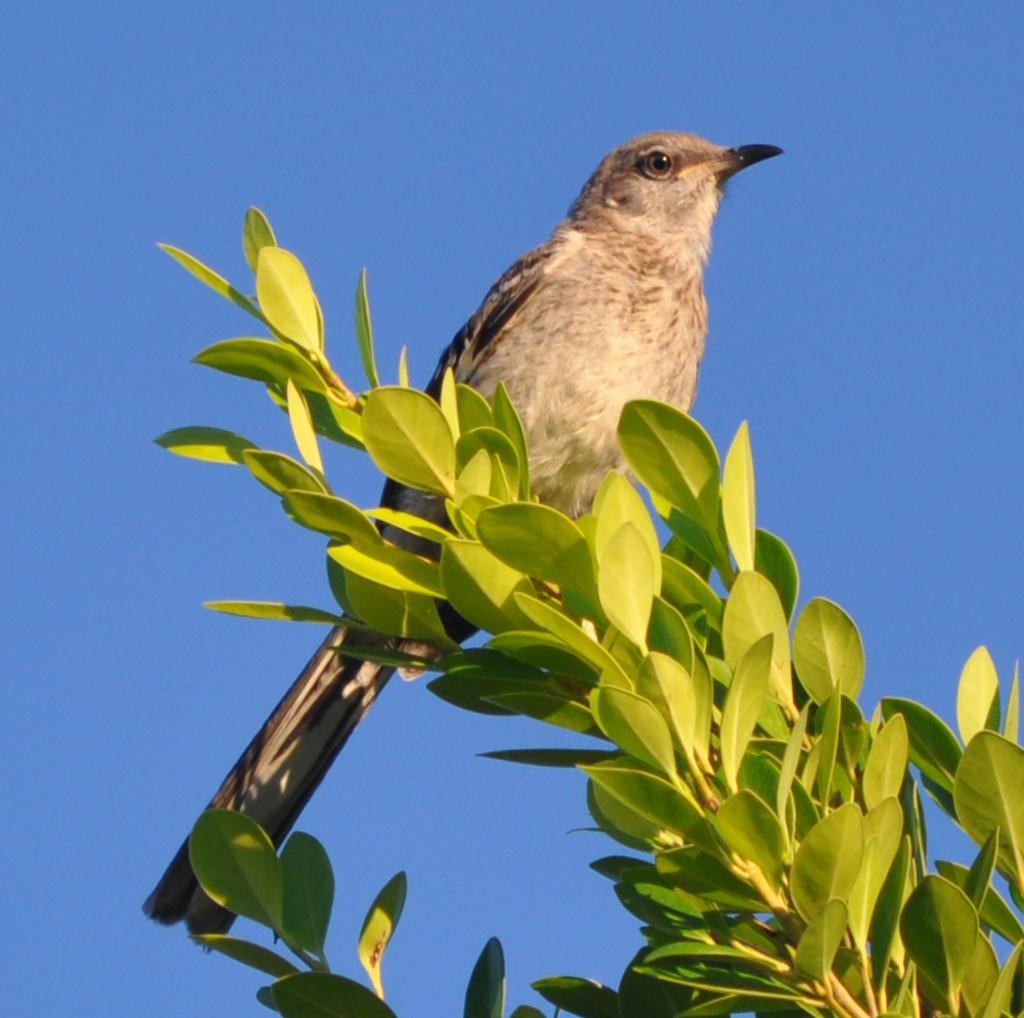In one or two sentences, can you explain what this image depicts? In this picture I can see there is a bird sitting on the stem and it has some leaves. The sky is clear. 